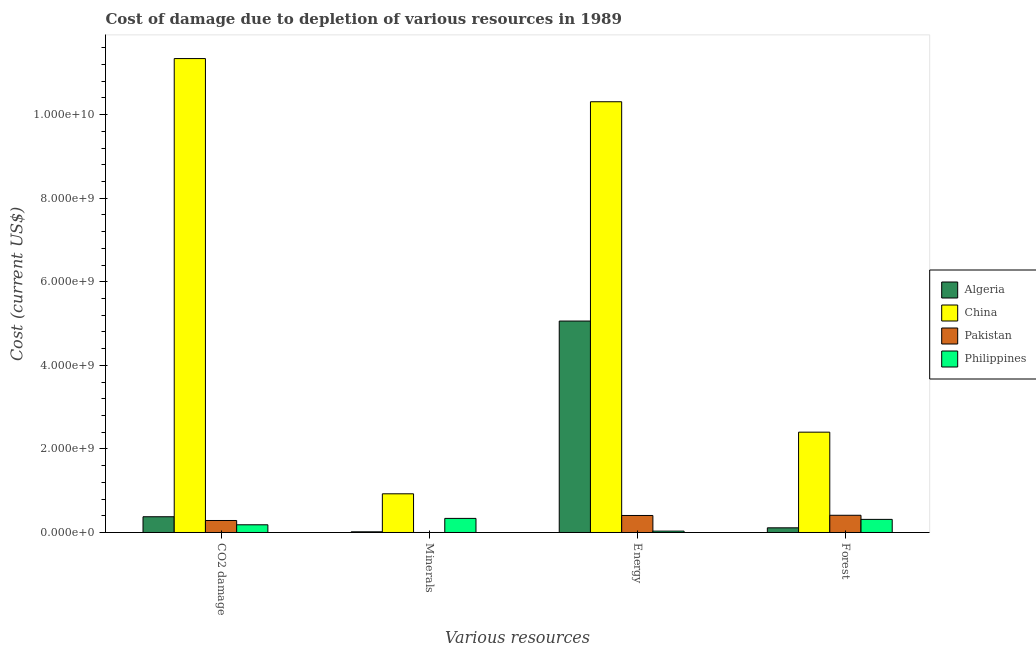How many groups of bars are there?
Provide a succinct answer. 4. Are the number of bars per tick equal to the number of legend labels?
Your response must be concise. Yes. Are the number of bars on each tick of the X-axis equal?
Your answer should be very brief. Yes. How many bars are there on the 1st tick from the left?
Keep it short and to the point. 4. How many bars are there on the 4th tick from the right?
Give a very brief answer. 4. What is the label of the 2nd group of bars from the left?
Offer a terse response. Minerals. What is the cost of damage due to depletion of forests in Algeria?
Your response must be concise. 1.12e+08. Across all countries, what is the maximum cost of damage due to depletion of energy?
Ensure brevity in your answer.  1.03e+1. Across all countries, what is the minimum cost of damage due to depletion of coal?
Provide a short and direct response. 1.84e+08. In which country was the cost of damage due to depletion of forests maximum?
Provide a succinct answer. China. In which country was the cost of damage due to depletion of minerals minimum?
Give a very brief answer. Pakistan. What is the total cost of damage due to depletion of forests in the graph?
Provide a short and direct response. 3.24e+09. What is the difference between the cost of damage due to depletion of minerals in Algeria and that in China?
Give a very brief answer. -9.10e+08. What is the difference between the cost of damage due to depletion of minerals in Pakistan and the cost of damage due to depletion of energy in China?
Offer a terse response. -1.03e+1. What is the average cost of damage due to depletion of minerals per country?
Provide a short and direct response. 3.20e+08. What is the difference between the cost of damage due to depletion of coal and cost of damage due to depletion of minerals in Algeria?
Provide a succinct answer. 3.61e+08. What is the ratio of the cost of damage due to depletion of forests in Algeria to that in China?
Ensure brevity in your answer.  0.05. What is the difference between the highest and the second highest cost of damage due to depletion of forests?
Offer a terse response. 1.99e+09. What is the difference between the highest and the lowest cost of damage due to depletion of coal?
Provide a succinct answer. 1.12e+1. In how many countries, is the cost of damage due to depletion of forests greater than the average cost of damage due to depletion of forests taken over all countries?
Offer a terse response. 1. Is the sum of the cost of damage due to depletion of coal in Pakistan and Algeria greater than the maximum cost of damage due to depletion of minerals across all countries?
Keep it short and to the point. No. Is it the case that in every country, the sum of the cost of damage due to depletion of forests and cost of damage due to depletion of minerals is greater than the sum of cost of damage due to depletion of coal and cost of damage due to depletion of energy?
Keep it short and to the point. No. What does the 2nd bar from the right in Energy represents?
Provide a short and direct response. Pakistan. Is it the case that in every country, the sum of the cost of damage due to depletion of coal and cost of damage due to depletion of minerals is greater than the cost of damage due to depletion of energy?
Provide a succinct answer. No. Are all the bars in the graph horizontal?
Provide a short and direct response. No. Are the values on the major ticks of Y-axis written in scientific E-notation?
Provide a succinct answer. Yes. Does the graph contain any zero values?
Offer a very short reply. No. Does the graph contain grids?
Provide a succinct answer. No. How are the legend labels stacked?
Your response must be concise. Vertical. What is the title of the graph?
Offer a terse response. Cost of damage due to depletion of various resources in 1989 . What is the label or title of the X-axis?
Your response must be concise. Various resources. What is the label or title of the Y-axis?
Ensure brevity in your answer.  Cost (current US$). What is the Cost (current US$) in Algeria in CO2 damage?
Offer a terse response. 3.77e+08. What is the Cost (current US$) of China in CO2 damage?
Your answer should be very brief. 1.13e+1. What is the Cost (current US$) in Pakistan in CO2 damage?
Your response must be concise. 2.87e+08. What is the Cost (current US$) in Philippines in CO2 damage?
Provide a succinct answer. 1.84e+08. What is the Cost (current US$) in Algeria in Minerals?
Make the answer very short. 1.62e+07. What is the Cost (current US$) in China in Minerals?
Make the answer very short. 9.26e+08. What is the Cost (current US$) of Pakistan in Minerals?
Give a very brief answer. 2.33e+04. What is the Cost (current US$) in Philippines in Minerals?
Offer a terse response. 3.37e+08. What is the Cost (current US$) of Algeria in Energy?
Offer a very short reply. 5.06e+09. What is the Cost (current US$) in China in Energy?
Make the answer very short. 1.03e+1. What is the Cost (current US$) of Pakistan in Energy?
Ensure brevity in your answer.  4.07e+08. What is the Cost (current US$) of Philippines in Energy?
Give a very brief answer. 3.27e+07. What is the Cost (current US$) in Algeria in Forest?
Give a very brief answer. 1.12e+08. What is the Cost (current US$) of China in Forest?
Provide a succinct answer. 2.40e+09. What is the Cost (current US$) in Pakistan in Forest?
Provide a succinct answer. 4.12e+08. What is the Cost (current US$) of Philippines in Forest?
Offer a terse response. 3.14e+08. Across all Various resources, what is the maximum Cost (current US$) in Algeria?
Give a very brief answer. 5.06e+09. Across all Various resources, what is the maximum Cost (current US$) of China?
Your answer should be compact. 1.13e+1. Across all Various resources, what is the maximum Cost (current US$) of Pakistan?
Your answer should be compact. 4.12e+08. Across all Various resources, what is the maximum Cost (current US$) in Philippines?
Your answer should be compact. 3.37e+08. Across all Various resources, what is the minimum Cost (current US$) in Algeria?
Your response must be concise. 1.62e+07. Across all Various resources, what is the minimum Cost (current US$) in China?
Offer a terse response. 9.26e+08. Across all Various resources, what is the minimum Cost (current US$) of Pakistan?
Offer a terse response. 2.33e+04. Across all Various resources, what is the minimum Cost (current US$) in Philippines?
Your answer should be compact. 3.27e+07. What is the total Cost (current US$) in Algeria in the graph?
Keep it short and to the point. 5.57e+09. What is the total Cost (current US$) of China in the graph?
Your answer should be compact. 2.50e+1. What is the total Cost (current US$) in Pakistan in the graph?
Offer a terse response. 1.11e+09. What is the total Cost (current US$) of Philippines in the graph?
Provide a short and direct response. 8.68e+08. What is the difference between the Cost (current US$) in Algeria in CO2 damage and that in Minerals?
Give a very brief answer. 3.61e+08. What is the difference between the Cost (current US$) of China in CO2 damage and that in Minerals?
Give a very brief answer. 1.04e+1. What is the difference between the Cost (current US$) of Pakistan in CO2 damage and that in Minerals?
Your response must be concise. 2.87e+08. What is the difference between the Cost (current US$) of Philippines in CO2 damage and that in Minerals?
Offer a terse response. -1.53e+08. What is the difference between the Cost (current US$) of Algeria in CO2 damage and that in Energy?
Offer a very short reply. -4.68e+09. What is the difference between the Cost (current US$) in China in CO2 damage and that in Energy?
Give a very brief answer. 1.03e+09. What is the difference between the Cost (current US$) in Pakistan in CO2 damage and that in Energy?
Your answer should be compact. -1.20e+08. What is the difference between the Cost (current US$) in Philippines in CO2 damage and that in Energy?
Offer a terse response. 1.52e+08. What is the difference between the Cost (current US$) of Algeria in CO2 damage and that in Forest?
Your response must be concise. 2.65e+08. What is the difference between the Cost (current US$) of China in CO2 damage and that in Forest?
Give a very brief answer. 8.94e+09. What is the difference between the Cost (current US$) of Pakistan in CO2 damage and that in Forest?
Your answer should be compact. -1.25e+08. What is the difference between the Cost (current US$) in Philippines in CO2 damage and that in Forest?
Provide a succinct answer. -1.29e+08. What is the difference between the Cost (current US$) of Algeria in Minerals and that in Energy?
Ensure brevity in your answer.  -5.04e+09. What is the difference between the Cost (current US$) in China in Minerals and that in Energy?
Your answer should be very brief. -9.38e+09. What is the difference between the Cost (current US$) of Pakistan in Minerals and that in Energy?
Your answer should be very brief. -4.07e+08. What is the difference between the Cost (current US$) in Philippines in Minerals and that in Energy?
Your answer should be very brief. 3.04e+08. What is the difference between the Cost (current US$) in Algeria in Minerals and that in Forest?
Offer a very short reply. -9.56e+07. What is the difference between the Cost (current US$) of China in Minerals and that in Forest?
Offer a very short reply. -1.48e+09. What is the difference between the Cost (current US$) in Pakistan in Minerals and that in Forest?
Your response must be concise. -4.12e+08. What is the difference between the Cost (current US$) of Philippines in Minerals and that in Forest?
Your answer should be compact. 2.35e+07. What is the difference between the Cost (current US$) in Algeria in Energy and that in Forest?
Provide a short and direct response. 4.95e+09. What is the difference between the Cost (current US$) in China in Energy and that in Forest?
Offer a terse response. 7.91e+09. What is the difference between the Cost (current US$) in Pakistan in Energy and that in Forest?
Ensure brevity in your answer.  -4.92e+06. What is the difference between the Cost (current US$) of Philippines in Energy and that in Forest?
Provide a short and direct response. -2.81e+08. What is the difference between the Cost (current US$) of Algeria in CO2 damage and the Cost (current US$) of China in Minerals?
Your response must be concise. -5.49e+08. What is the difference between the Cost (current US$) in Algeria in CO2 damage and the Cost (current US$) in Pakistan in Minerals?
Offer a very short reply. 3.77e+08. What is the difference between the Cost (current US$) of Algeria in CO2 damage and the Cost (current US$) of Philippines in Minerals?
Give a very brief answer. 3.98e+07. What is the difference between the Cost (current US$) of China in CO2 damage and the Cost (current US$) of Pakistan in Minerals?
Ensure brevity in your answer.  1.13e+1. What is the difference between the Cost (current US$) in China in CO2 damage and the Cost (current US$) in Philippines in Minerals?
Ensure brevity in your answer.  1.10e+1. What is the difference between the Cost (current US$) in Pakistan in CO2 damage and the Cost (current US$) in Philippines in Minerals?
Provide a short and direct response. -5.01e+07. What is the difference between the Cost (current US$) of Algeria in CO2 damage and the Cost (current US$) of China in Energy?
Keep it short and to the point. -9.93e+09. What is the difference between the Cost (current US$) of Algeria in CO2 damage and the Cost (current US$) of Pakistan in Energy?
Give a very brief answer. -3.00e+07. What is the difference between the Cost (current US$) in Algeria in CO2 damage and the Cost (current US$) in Philippines in Energy?
Your answer should be very brief. 3.44e+08. What is the difference between the Cost (current US$) in China in CO2 damage and the Cost (current US$) in Pakistan in Energy?
Keep it short and to the point. 1.09e+1. What is the difference between the Cost (current US$) of China in CO2 damage and the Cost (current US$) of Philippines in Energy?
Your response must be concise. 1.13e+1. What is the difference between the Cost (current US$) of Pakistan in CO2 damage and the Cost (current US$) of Philippines in Energy?
Your answer should be compact. 2.54e+08. What is the difference between the Cost (current US$) of Algeria in CO2 damage and the Cost (current US$) of China in Forest?
Ensure brevity in your answer.  -2.02e+09. What is the difference between the Cost (current US$) of Algeria in CO2 damage and the Cost (current US$) of Pakistan in Forest?
Your answer should be very brief. -3.49e+07. What is the difference between the Cost (current US$) in Algeria in CO2 damage and the Cost (current US$) in Philippines in Forest?
Offer a terse response. 6.32e+07. What is the difference between the Cost (current US$) of China in CO2 damage and the Cost (current US$) of Pakistan in Forest?
Offer a terse response. 1.09e+1. What is the difference between the Cost (current US$) in China in CO2 damage and the Cost (current US$) in Philippines in Forest?
Provide a succinct answer. 1.10e+1. What is the difference between the Cost (current US$) of Pakistan in CO2 damage and the Cost (current US$) of Philippines in Forest?
Make the answer very short. -2.67e+07. What is the difference between the Cost (current US$) of Algeria in Minerals and the Cost (current US$) of China in Energy?
Your response must be concise. -1.03e+1. What is the difference between the Cost (current US$) of Algeria in Minerals and the Cost (current US$) of Pakistan in Energy?
Provide a short and direct response. -3.91e+08. What is the difference between the Cost (current US$) of Algeria in Minerals and the Cost (current US$) of Philippines in Energy?
Keep it short and to the point. -1.65e+07. What is the difference between the Cost (current US$) in China in Minerals and the Cost (current US$) in Pakistan in Energy?
Provide a succinct answer. 5.19e+08. What is the difference between the Cost (current US$) of China in Minerals and the Cost (current US$) of Philippines in Energy?
Make the answer very short. 8.93e+08. What is the difference between the Cost (current US$) in Pakistan in Minerals and the Cost (current US$) in Philippines in Energy?
Your answer should be very brief. -3.27e+07. What is the difference between the Cost (current US$) in Algeria in Minerals and the Cost (current US$) in China in Forest?
Make the answer very short. -2.38e+09. What is the difference between the Cost (current US$) of Algeria in Minerals and the Cost (current US$) of Pakistan in Forest?
Offer a very short reply. -3.96e+08. What is the difference between the Cost (current US$) of Algeria in Minerals and the Cost (current US$) of Philippines in Forest?
Give a very brief answer. -2.98e+08. What is the difference between the Cost (current US$) in China in Minerals and the Cost (current US$) in Pakistan in Forest?
Provide a succinct answer. 5.14e+08. What is the difference between the Cost (current US$) of China in Minerals and the Cost (current US$) of Philippines in Forest?
Your answer should be very brief. 6.12e+08. What is the difference between the Cost (current US$) in Pakistan in Minerals and the Cost (current US$) in Philippines in Forest?
Make the answer very short. -3.14e+08. What is the difference between the Cost (current US$) in Algeria in Energy and the Cost (current US$) in China in Forest?
Offer a very short reply. 2.66e+09. What is the difference between the Cost (current US$) in Algeria in Energy and the Cost (current US$) in Pakistan in Forest?
Provide a succinct answer. 4.65e+09. What is the difference between the Cost (current US$) of Algeria in Energy and the Cost (current US$) of Philippines in Forest?
Provide a succinct answer. 4.75e+09. What is the difference between the Cost (current US$) of China in Energy and the Cost (current US$) of Pakistan in Forest?
Make the answer very short. 9.90e+09. What is the difference between the Cost (current US$) in China in Energy and the Cost (current US$) in Philippines in Forest?
Your response must be concise. 1.00e+1. What is the difference between the Cost (current US$) of Pakistan in Energy and the Cost (current US$) of Philippines in Forest?
Your response must be concise. 9.33e+07. What is the average Cost (current US$) in Algeria per Various resources?
Give a very brief answer. 1.39e+09. What is the average Cost (current US$) in China per Various resources?
Offer a terse response. 6.25e+09. What is the average Cost (current US$) of Pakistan per Various resources?
Keep it short and to the point. 2.77e+08. What is the average Cost (current US$) in Philippines per Various resources?
Keep it short and to the point. 2.17e+08. What is the difference between the Cost (current US$) of Algeria and Cost (current US$) of China in CO2 damage?
Offer a very short reply. -1.10e+1. What is the difference between the Cost (current US$) in Algeria and Cost (current US$) in Pakistan in CO2 damage?
Your response must be concise. 8.99e+07. What is the difference between the Cost (current US$) of Algeria and Cost (current US$) of Philippines in CO2 damage?
Provide a short and direct response. 1.93e+08. What is the difference between the Cost (current US$) in China and Cost (current US$) in Pakistan in CO2 damage?
Your answer should be compact. 1.11e+1. What is the difference between the Cost (current US$) in China and Cost (current US$) in Philippines in CO2 damage?
Give a very brief answer. 1.12e+1. What is the difference between the Cost (current US$) in Pakistan and Cost (current US$) in Philippines in CO2 damage?
Offer a very short reply. 1.03e+08. What is the difference between the Cost (current US$) in Algeria and Cost (current US$) in China in Minerals?
Your answer should be very brief. -9.10e+08. What is the difference between the Cost (current US$) in Algeria and Cost (current US$) in Pakistan in Minerals?
Give a very brief answer. 1.62e+07. What is the difference between the Cost (current US$) in Algeria and Cost (current US$) in Philippines in Minerals?
Offer a very short reply. -3.21e+08. What is the difference between the Cost (current US$) of China and Cost (current US$) of Pakistan in Minerals?
Keep it short and to the point. 9.26e+08. What is the difference between the Cost (current US$) of China and Cost (current US$) of Philippines in Minerals?
Your answer should be very brief. 5.89e+08. What is the difference between the Cost (current US$) of Pakistan and Cost (current US$) of Philippines in Minerals?
Your response must be concise. -3.37e+08. What is the difference between the Cost (current US$) in Algeria and Cost (current US$) in China in Energy?
Keep it short and to the point. -5.25e+09. What is the difference between the Cost (current US$) in Algeria and Cost (current US$) in Pakistan in Energy?
Ensure brevity in your answer.  4.65e+09. What is the difference between the Cost (current US$) in Algeria and Cost (current US$) in Philippines in Energy?
Give a very brief answer. 5.03e+09. What is the difference between the Cost (current US$) in China and Cost (current US$) in Pakistan in Energy?
Your answer should be compact. 9.90e+09. What is the difference between the Cost (current US$) of China and Cost (current US$) of Philippines in Energy?
Make the answer very short. 1.03e+1. What is the difference between the Cost (current US$) of Pakistan and Cost (current US$) of Philippines in Energy?
Your response must be concise. 3.74e+08. What is the difference between the Cost (current US$) of Algeria and Cost (current US$) of China in Forest?
Keep it short and to the point. -2.29e+09. What is the difference between the Cost (current US$) in Algeria and Cost (current US$) in Pakistan in Forest?
Make the answer very short. -3.00e+08. What is the difference between the Cost (current US$) in Algeria and Cost (current US$) in Philippines in Forest?
Your response must be concise. -2.02e+08. What is the difference between the Cost (current US$) in China and Cost (current US$) in Pakistan in Forest?
Your response must be concise. 1.99e+09. What is the difference between the Cost (current US$) in China and Cost (current US$) in Philippines in Forest?
Your answer should be compact. 2.09e+09. What is the difference between the Cost (current US$) in Pakistan and Cost (current US$) in Philippines in Forest?
Your answer should be very brief. 9.82e+07. What is the ratio of the Cost (current US$) of Algeria in CO2 damage to that in Minerals?
Provide a succinct answer. 23.25. What is the ratio of the Cost (current US$) of China in CO2 damage to that in Minerals?
Offer a very short reply. 12.25. What is the ratio of the Cost (current US$) of Pakistan in CO2 damage to that in Minerals?
Your answer should be compact. 1.23e+04. What is the ratio of the Cost (current US$) of Philippines in CO2 damage to that in Minerals?
Offer a very short reply. 0.55. What is the ratio of the Cost (current US$) in Algeria in CO2 damage to that in Energy?
Keep it short and to the point. 0.07. What is the ratio of the Cost (current US$) of China in CO2 damage to that in Energy?
Your answer should be very brief. 1.1. What is the ratio of the Cost (current US$) in Pakistan in CO2 damage to that in Energy?
Make the answer very short. 0.71. What is the ratio of the Cost (current US$) in Philippines in CO2 damage to that in Energy?
Your response must be concise. 5.63. What is the ratio of the Cost (current US$) in Algeria in CO2 damage to that in Forest?
Keep it short and to the point. 3.37. What is the ratio of the Cost (current US$) in China in CO2 damage to that in Forest?
Make the answer very short. 4.72. What is the ratio of the Cost (current US$) of Pakistan in CO2 damage to that in Forest?
Your answer should be very brief. 0.7. What is the ratio of the Cost (current US$) in Philippines in CO2 damage to that in Forest?
Offer a very short reply. 0.59. What is the ratio of the Cost (current US$) of Algeria in Minerals to that in Energy?
Your answer should be compact. 0. What is the ratio of the Cost (current US$) in China in Minerals to that in Energy?
Provide a succinct answer. 0.09. What is the ratio of the Cost (current US$) in Philippines in Minerals to that in Energy?
Make the answer very short. 10.31. What is the ratio of the Cost (current US$) in Algeria in Minerals to that in Forest?
Ensure brevity in your answer.  0.14. What is the ratio of the Cost (current US$) of China in Minerals to that in Forest?
Make the answer very short. 0.39. What is the ratio of the Cost (current US$) in Pakistan in Minerals to that in Forest?
Provide a short and direct response. 0. What is the ratio of the Cost (current US$) in Philippines in Minerals to that in Forest?
Offer a terse response. 1.07. What is the ratio of the Cost (current US$) of Algeria in Energy to that in Forest?
Offer a terse response. 45.25. What is the ratio of the Cost (current US$) in China in Energy to that in Forest?
Provide a succinct answer. 4.29. What is the ratio of the Cost (current US$) in Philippines in Energy to that in Forest?
Offer a terse response. 0.1. What is the difference between the highest and the second highest Cost (current US$) of Algeria?
Your response must be concise. 4.68e+09. What is the difference between the highest and the second highest Cost (current US$) in China?
Ensure brevity in your answer.  1.03e+09. What is the difference between the highest and the second highest Cost (current US$) of Pakistan?
Provide a short and direct response. 4.92e+06. What is the difference between the highest and the second highest Cost (current US$) of Philippines?
Your answer should be compact. 2.35e+07. What is the difference between the highest and the lowest Cost (current US$) in Algeria?
Provide a succinct answer. 5.04e+09. What is the difference between the highest and the lowest Cost (current US$) in China?
Make the answer very short. 1.04e+1. What is the difference between the highest and the lowest Cost (current US$) of Pakistan?
Provide a short and direct response. 4.12e+08. What is the difference between the highest and the lowest Cost (current US$) of Philippines?
Ensure brevity in your answer.  3.04e+08. 